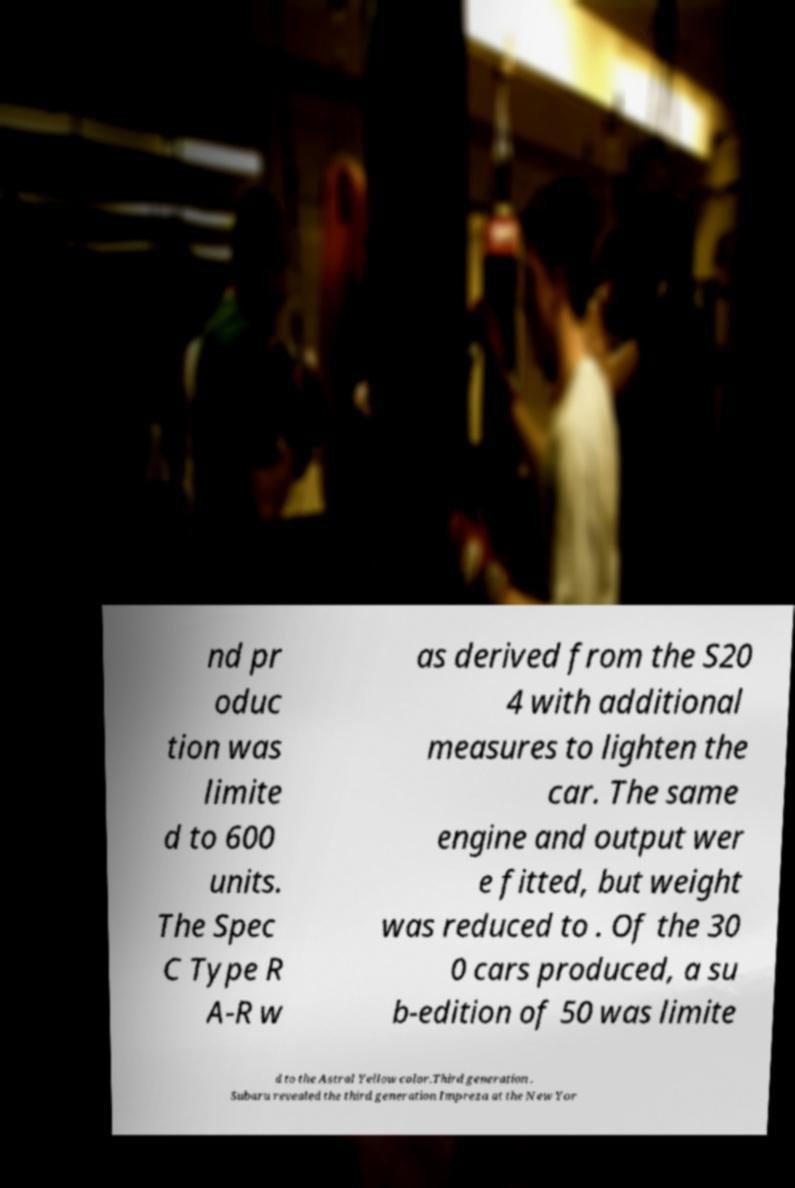Please identify and transcribe the text found in this image. nd pr oduc tion was limite d to 600 units. The Spec C Type R A-R w as derived from the S20 4 with additional measures to lighten the car. The same engine and output wer e fitted, but weight was reduced to . Of the 30 0 cars produced, a su b-edition of 50 was limite d to the Astral Yellow color.Third generation . Subaru revealed the third generation Impreza at the New Yor 